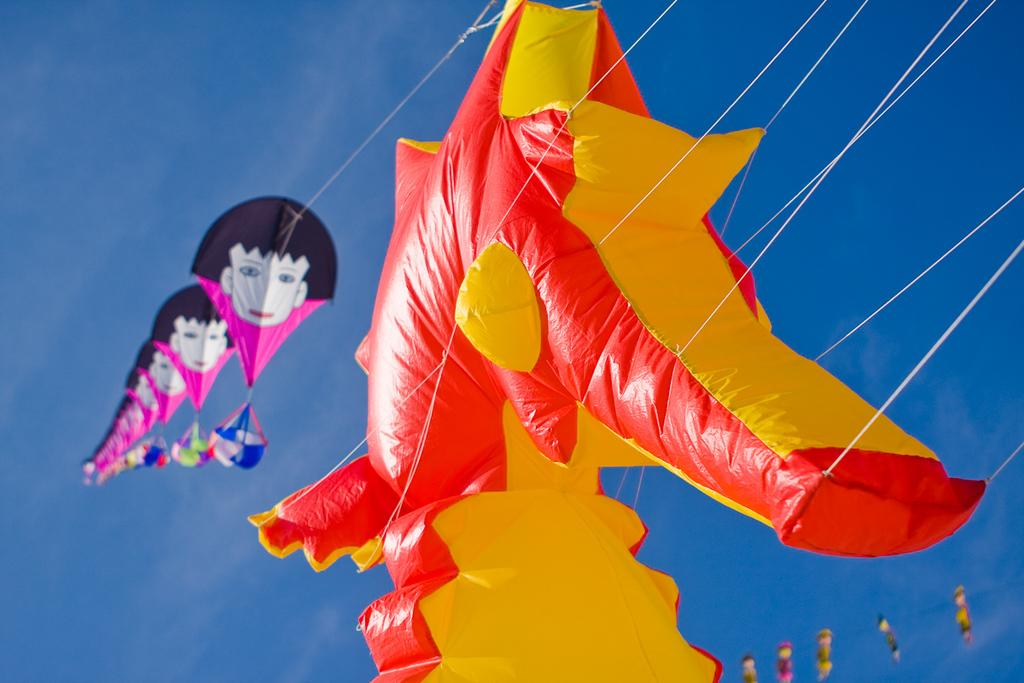What objects are visible in the image? There are kites in the image. Where are the kites located in the image? The kites are flying in the middle of the air. How are the kites being controlled in the image? The kites have strings attached to them. What type of humor can be seen on the side of the kites in the image? There is no humor present on the kites or their sides in the image. 